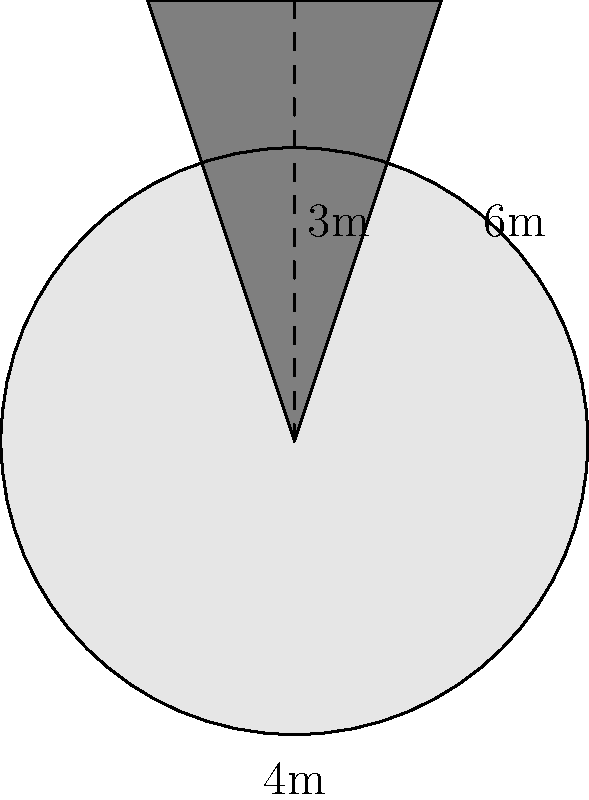A local artist has created a triangular prism sculpture for a public space. The sculpture has a circular base with a diameter of 4 meters and a height of 3 meters. If the triangular face has a base width of 4 meters and a height of 6 meters, what is the total surface area of the sculpture in square meters? (Use $\pi \approx 3.14$ for calculations) To calculate the total surface area, we need to add the areas of all surfaces:

1. Area of the circular base:
   $A_{base} = \pi r^2 = \pi (2m)^2 = 4\pi m^2 \approx 12.56 m^2$

2. Area of the triangular face (repeated twice):
   $A_{triangle} = \frac{1}{2} \times base \times height = \frac{1}{2} \times 4m \times 6m = 12 m^2$
   Total for both triangular faces: $2 \times 12 m^2 = 24 m^2$

3. Area of the curved rectangular side:
   $A_{side} = circumference \times height = 2\pi r \times height = 2\pi \times 2m \times 3m = 12\pi m^2 \approx 37.68 m^2$

Total surface area:
$A_{total} = A_{base} + 2A_{triangle} + A_{side}$
$A_{total} \approx 12.56 m^2 + 24 m^2 + 37.68 m^2 = 74.24 m^2$
Answer: 74.24 m² 